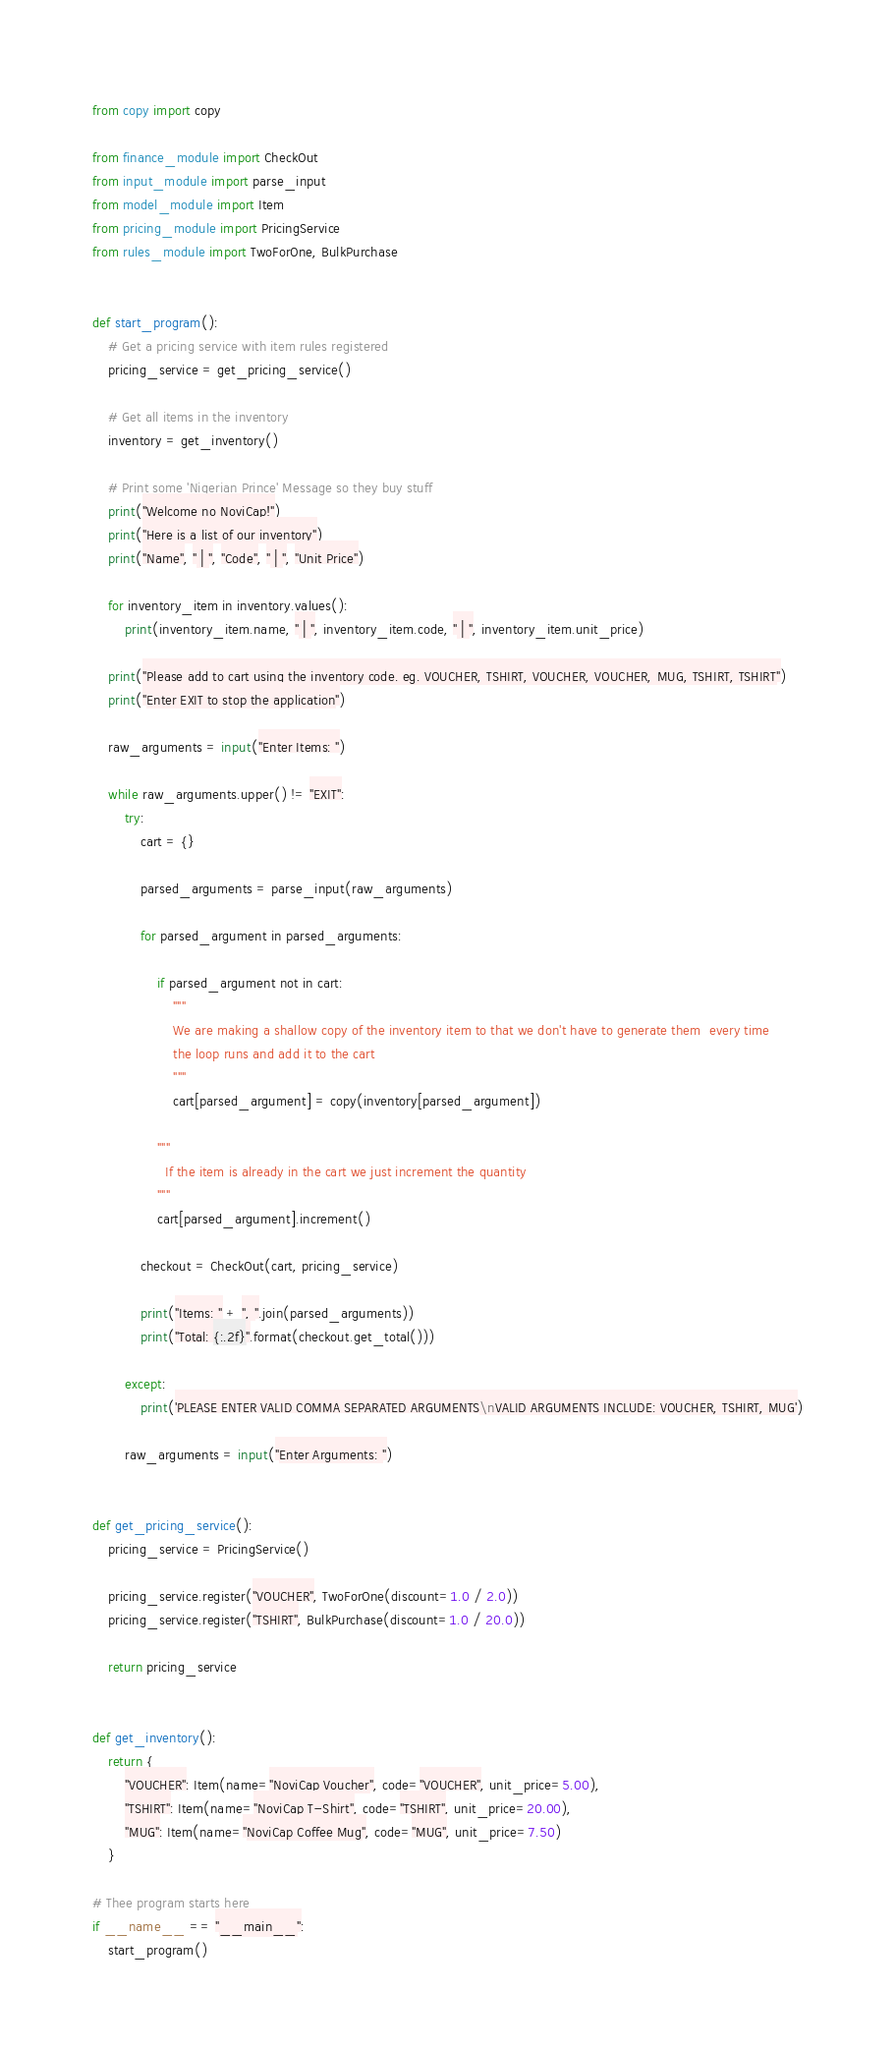Convert code to text. <code><loc_0><loc_0><loc_500><loc_500><_Python_>from copy import copy

from finance_module import CheckOut
from input_module import parse_input
from model_module import Item
from pricing_module import PricingService
from rules_module import TwoForOne, BulkPurchase


def start_program():
    # Get a pricing service with item rules registered
    pricing_service = get_pricing_service()

    # Get all items in the inventory
    inventory = get_inventory()

    # Print some 'Nigerian Prince' Message so they buy stuff
    print("Welcome no NoviCap!")
    print("Here is a list of our inventory")
    print("Name", " | ", "Code", " | ", "Unit Price")

    for inventory_item in inventory.values():
        print(inventory_item.name, " | ", inventory_item.code, " | ", inventory_item.unit_price)

    print("Please add to cart using the inventory code. eg. VOUCHER, TSHIRT, VOUCHER, VOUCHER, MUG, TSHIRT, TSHIRT")
    print("Enter EXIT to stop the application")

    raw_arguments = input("Enter Items: ")

    while raw_arguments.upper() != "EXIT":
        try:
            cart = {}

            parsed_arguments = parse_input(raw_arguments)

            for parsed_argument in parsed_arguments:

                if parsed_argument not in cart:
                    """
                    We are making a shallow copy of the inventory item to that we don't have to generate them  every time
                    the loop runs and add it to the cart
                    """
                    cart[parsed_argument] = copy(inventory[parsed_argument])

                """
                  If the item is already in the cart we just increment the quantity
                """
                cart[parsed_argument].increment()

            checkout = CheckOut(cart, pricing_service)

            print("Items: " + ", ".join(parsed_arguments))
            print("Total: {:.2f}".format(checkout.get_total()))

        except:
            print('PLEASE ENTER VALID COMMA SEPARATED ARGUMENTS\nVALID ARGUMENTS INCLUDE: VOUCHER, TSHIRT, MUG')

        raw_arguments = input("Enter Arguments: ")


def get_pricing_service():
    pricing_service = PricingService()

    pricing_service.register("VOUCHER", TwoForOne(discount=1.0 / 2.0))
    pricing_service.register("TSHIRT", BulkPurchase(discount=1.0 / 20.0))

    return pricing_service


def get_inventory():
    return {
        "VOUCHER": Item(name="NoviCap Voucher", code="VOUCHER", unit_price=5.00),
        "TSHIRT": Item(name="NoviCap T-Shirt", code="TSHIRT", unit_price=20.00),
        "MUG": Item(name="NoviCap Coffee Mug", code="MUG", unit_price=7.50)
    }

# Thee program starts here
if __name__ == "__main__":
    start_program()
</code> 